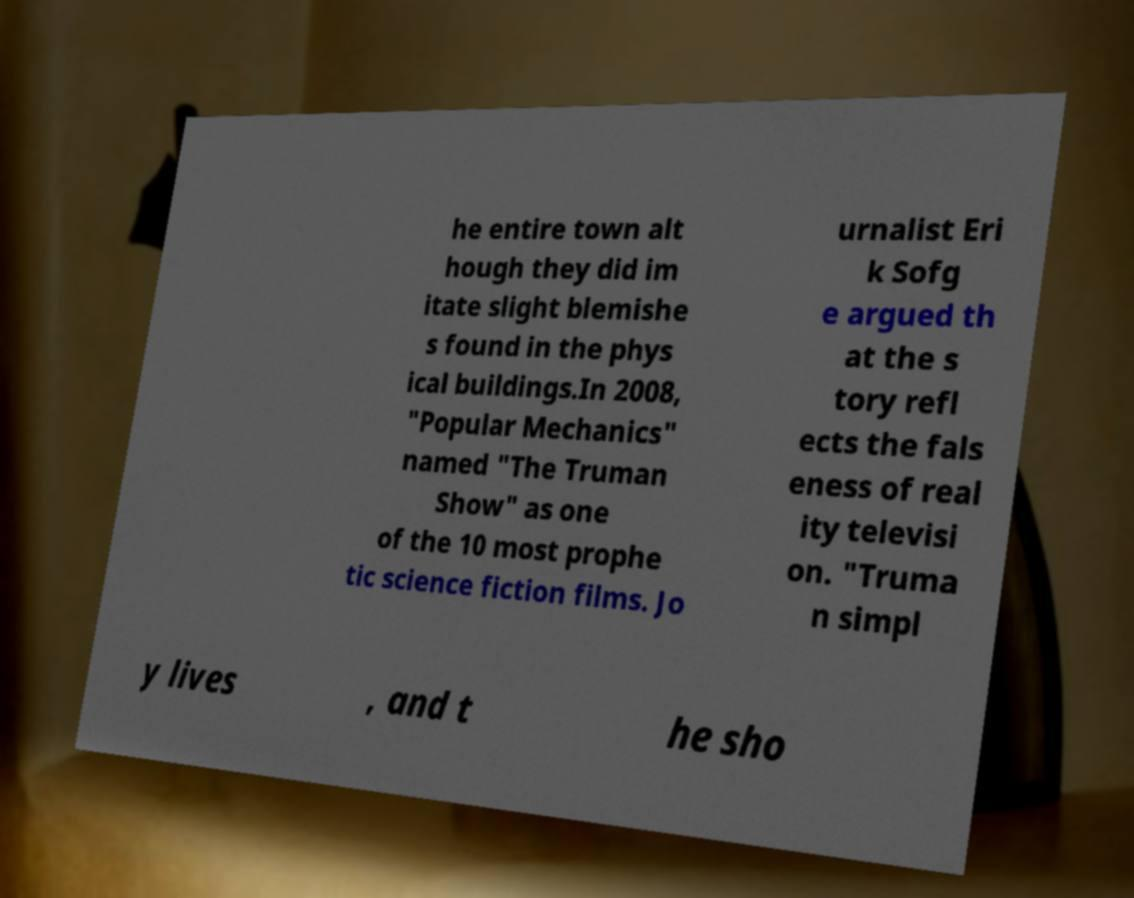I need the written content from this picture converted into text. Can you do that? he entire town alt hough they did im itate slight blemishe s found in the phys ical buildings.In 2008, "Popular Mechanics" named "The Truman Show" as one of the 10 most prophe tic science fiction films. Jo urnalist Eri k Sofg e argued th at the s tory refl ects the fals eness of real ity televisi on. "Truma n simpl y lives , and t he sho 